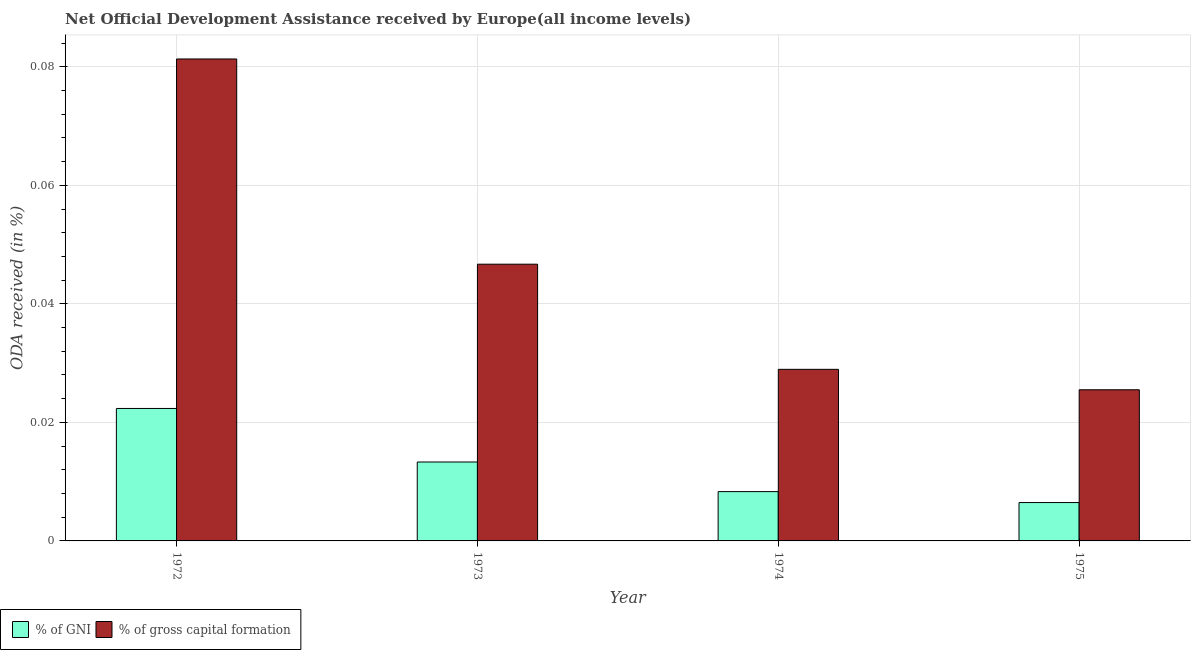How many groups of bars are there?
Your response must be concise. 4. Are the number of bars per tick equal to the number of legend labels?
Your response must be concise. Yes. Are the number of bars on each tick of the X-axis equal?
Give a very brief answer. Yes. What is the label of the 4th group of bars from the left?
Provide a short and direct response. 1975. What is the oda received as percentage of gross capital formation in 1975?
Offer a terse response. 0.03. Across all years, what is the maximum oda received as percentage of gni?
Offer a terse response. 0.02. Across all years, what is the minimum oda received as percentage of gni?
Your response must be concise. 0.01. In which year was the oda received as percentage of gni minimum?
Your answer should be compact. 1975. What is the total oda received as percentage of gross capital formation in the graph?
Your response must be concise. 0.18. What is the difference between the oda received as percentage of gni in 1973 and that in 1974?
Make the answer very short. 0. What is the difference between the oda received as percentage of gni in 1973 and the oda received as percentage of gross capital formation in 1975?
Offer a very short reply. 0.01. What is the average oda received as percentage of gross capital formation per year?
Provide a short and direct response. 0.05. In the year 1973, what is the difference between the oda received as percentage of gross capital formation and oda received as percentage of gni?
Offer a very short reply. 0. In how many years, is the oda received as percentage of gni greater than 0.064 %?
Offer a terse response. 0. What is the ratio of the oda received as percentage of gni in 1972 to that in 1974?
Offer a terse response. 2.69. What is the difference between the highest and the second highest oda received as percentage of gni?
Offer a terse response. 0.01. What is the difference between the highest and the lowest oda received as percentage of gni?
Ensure brevity in your answer.  0.02. What does the 2nd bar from the left in 1973 represents?
Ensure brevity in your answer.  % of gross capital formation. What does the 2nd bar from the right in 1974 represents?
Keep it short and to the point. % of GNI. What is the difference between two consecutive major ticks on the Y-axis?
Give a very brief answer. 0.02. Does the graph contain any zero values?
Give a very brief answer. No. How many legend labels are there?
Your response must be concise. 2. What is the title of the graph?
Your answer should be compact. Net Official Development Assistance received by Europe(all income levels). What is the label or title of the X-axis?
Your response must be concise. Year. What is the label or title of the Y-axis?
Give a very brief answer. ODA received (in %). What is the ODA received (in %) in % of GNI in 1972?
Make the answer very short. 0.02. What is the ODA received (in %) of % of gross capital formation in 1972?
Your response must be concise. 0.08. What is the ODA received (in %) in % of GNI in 1973?
Give a very brief answer. 0.01. What is the ODA received (in %) of % of gross capital formation in 1973?
Your response must be concise. 0.05. What is the ODA received (in %) in % of GNI in 1974?
Make the answer very short. 0.01. What is the ODA received (in %) in % of gross capital formation in 1974?
Offer a very short reply. 0.03. What is the ODA received (in %) in % of GNI in 1975?
Provide a succinct answer. 0.01. What is the ODA received (in %) in % of gross capital formation in 1975?
Offer a very short reply. 0.03. Across all years, what is the maximum ODA received (in %) in % of GNI?
Ensure brevity in your answer.  0.02. Across all years, what is the maximum ODA received (in %) in % of gross capital formation?
Keep it short and to the point. 0.08. Across all years, what is the minimum ODA received (in %) of % of GNI?
Keep it short and to the point. 0.01. Across all years, what is the minimum ODA received (in %) of % of gross capital formation?
Your answer should be compact. 0.03. What is the total ODA received (in %) of % of GNI in the graph?
Your answer should be compact. 0.05. What is the total ODA received (in %) in % of gross capital formation in the graph?
Your answer should be very brief. 0.18. What is the difference between the ODA received (in %) of % of GNI in 1972 and that in 1973?
Provide a short and direct response. 0.01. What is the difference between the ODA received (in %) of % of gross capital formation in 1972 and that in 1973?
Your answer should be very brief. 0.03. What is the difference between the ODA received (in %) in % of GNI in 1972 and that in 1974?
Offer a very short reply. 0.01. What is the difference between the ODA received (in %) in % of gross capital formation in 1972 and that in 1974?
Make the answer very short. 0.05. What is the difference between the ODA received (in %) in % of GNI in 1972 and that in 1975?
Keep it short and to the point. 0.02. What is the difference between the ODA received (in %) in % of gross capital formation in 1972 and that in 1975?
Your answer should be compact. 0.06. What is the difference between the ODA received (in %) in % of GNI in 1973 and that in 1974?
Provide a short and direct response. 0.01. What is the difference between the ODA received (in %) in % of gross capital formation in 1973 and that in 1974?
Provide a short and direct response. 0.02. What is the difference between the ODA received (in %) of % of GNI in 1973 and that in 1975?
Your response must be concise. 0.01. What is the difference between the ODA received (in %) of % of gross capital formation in 1973 and that in 1975?
Your answer should be compact. 0.02. What is the difference between the ODA received (in %) of % of GNI in 1974 and that in 1975?
Ensure brevity in your answer.  0. What is the difference between the ODA received (in %) in % of gross capital formation in 1974 and that in 1975?
Provide a succinct answer. 0. What is the difference between the ODA received (in %) in % of GNI in 1972 and the ODA received (in %) in % of gross capital formation in 1973?
Ensure brevity in your answer.  -0.02. What is the difference between the ODA received (in %) of % of GNI in 1972 and the ODA received (in %) of % of gross capital formation in 1974?
Ensure brevity in your answer.  -0.01. What is the difference between the ODA received (in %) in % of GNI in 1972 and the ODA received (in %) in % of gross capital formation in 1975?
Provide a succinct answer. -0. What is the difference between the ODA received (in %) of % of GNI in 1973 and the ODA received (in %) of % of gross capital formation in 1974?
Ensure brevity in your answer.  -0.02. What is the difference between the ODA received (in %) in % of GNI in 1973 and the ODA received (in %) in % of gross capital formation in 1975?
Make the answer very short. -0.01. What is the difference between the ODA received (in %) in % of GNI in 1974 and the ODA received (in %) in % of gross capital formation in 1975?
Give a very brief answer. -0.02. What is the average ODA received (in %) of % of GNI per year?
Provide a short and direct response. 0.01. What is the average ODA received (in %) in % of gross capital formation per year?
Offer a very short reply. 0.05. In the year 1972, what is the difference between the ODA received (in %) in % of GNI and ODA received (in %) in % of gross capital formation?
Your answer should be compact. -0.06. In the year 1973, what is the difference between the ODA received (in %) in % of GNI and ODA received (in %) in % of gross capital formation?
Offer a terse response. -0.03. In the year 1974, what is the difference between the ODA received (in %) in % of GNI and ODA received (in %) in % of gross capital formation?
Offer a terse response. -0.02. In the year 1975, what is the difference between the ODA received (in %) in % of GNI and ODA received (in %) in % of gross capital formation?
Give a very brief answer. -0.02. What is the ratio of the ODA received (in %) in % of GNI in 1972 to that in 1973?
Your answer should be compact. 1.68. What is the ratio of the ODA received (in %) of % of gross capital formation in 1972 to that in 1973?
Ensure brevity in your answer.  1.74. What is the ratio of the ODA received (in %) in % of GNI in 1972 to that in 1974?
Keep it short and to the point. 2.69. What is the ratio of the ODA received (in %) of % of gross capital formation in 1972 to that in 1974?
Ensure brevity in your answer.  2.81. What is the ratio of the ODA received (in %) in % of GNI in 1972 to that in 1975?
Provide a succinct answer. 3.45. What is the ratio of the ODA received (in %) of % of gross capital formation in 1972 to that in 1975?
Provide a succinct answer. 3.19. What is the ratio of the ODA received (in %) in % of GNI in 1973 to that in 1974?
Keep it short and to the point. 1.6. What is the ratio of the ODA received (in %) of % of gross capital formation in 1973 to that in 1974?
Offer a very short reply. 1.61. What is the ratio of the ODA received (in %) of % of GNI in 1973 to that in 1975?
Provide a succinct answer. 2.06. What is the ratio of the ODA received (in %) in % of gross capital formation in 1973 to that in 1975?
Provide a succinct answer. 1.83. What is the ratio of the ODA received (in %) of % of GNI in 1974 to that in 1975?
Offer a very short reply. 1.28. What is the ratio of the ODA received (in %) of % of gross capital formation in 1974 to that in 1975?
Your response must be concise. 1.14. What is the difference between the highest and the second highest ODA received (in %) of % of GNI?
Your answer should be compact. 0.01. What is the difference between the highest and the second highest ODA received (in %) of % of gross capital formation?
Ensure brevity in your answer.  0.03. What is the difference between the highest and the lowest ODA received (in %) in % of GNI?
Offer a very short reply. 0.02. What is the difference between the highest and the lowest ODA received (in %) of % of gross capital formation?
Your answer should be very brief. 0.06. 